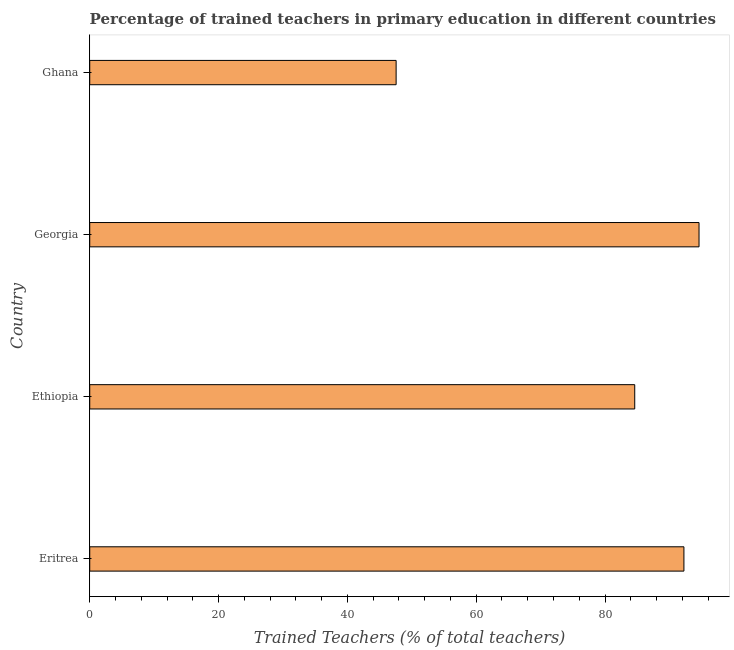Does the graph contain grids?
Give a very brief answer. No. What is the title of the graph?
Your response must be concise. Percentage of trained teachers in primary education in different countries. What is the label or title of the X-axis?
Provide a succinct answer. Trained Teachers (% of total teachers). What is the label or title of the Y-axis?
Provide a short and direct response. Country. What is the percentage of trained teachers in Georgia?
Your answer should be compact. 94.59. Across all countries, what is the maximum percentage of trained teachers?
Offer a very short reply. 94.59. Across all countries, what is the minimum percentage of trained teachers?
Provide a short and direct response. 47.57. In which country was the percentage of trained teachers maximum?
Provide a short and direct response. Georgia. In which country was the percentage of trained teachers minimum?
Make the answer very short. Ghana. What is the sum of the percentage of trained teachers?
Keep it short and to the point. 319.01. What is the difference between the percentage of trained teachers in Eritrea and Ghana?
Ensure brevity in your answer.  44.68. What is the average percentage of trained teachers per country?
Your answer should be compact. 79.75. What is the median percentage of trained teachers?
Your answer should be very brief. 88.43. In how many countries, is the percentage of trained teachers greater than 8 %?
Your answer should be compact. 4. What is the ratio of the percentage of trained teachers in Ethiopia to that in Georgia?
Offer a terse response. 0.89. What is the difference between the highest and the second highest percentage of trained teachers?
Make the answer very short. 2.34. What is the difference between the highest and the lowest percentage of trained teachers?
Make the answer very short. 47.02. How many bars are there?
Your response must be concise. 4. Are all the bars in the graph horizontal?
Give a very brief answer. Yes. How many countries are there in the graph?
Your response must be concise. 4. What is the difference between two consecutive major ticks on the X-axis?
Ensure brevity in your answer.  20. Are the values on the major ticks of X-axis written in scientific E-notation?
Give a very brief answer. No. What is the Trained Teachers (% of total teachers) in Eritrea?
Give a very brief answer. 92.25. What is the Trained Teachers (% of total teachers) in Ethiopia?
Ensure brevity in your answer.  84.61. What is the Trained Teachers (% of total teachers) in Georgia?
Offer a very short reply. 94.59. What is the Trained Teachers (% of total teachers) of Ghana?
Keep it short and to the point. 47.57. What is the difference between the Trained Teachers (% of total teachers) in Eritrea and Ethiopia?
Provide a succinct answer. 7.64. What is the difference between the Trained Teachers (% of total teachers) in Eritrea and Georgia?
Give a very brief answer. -2.34. What is the difference between the Trained Teachers (% of total teachers) in Eritrea and Ghana?
Offer a terse response. 44.68. What is the difference between the Trained Teachers (% of total teachers) in Ethiopia and Georgia?
Offer a terse response. -9.98. What is the difference between the Trained Teachers (% of total teachers) in Ethiopia and Ghana?
Make the answer very short. 37.04. What is the difference between the Trained Teachers (% of total teachers) in Georgia and Ghana?
Ensure brevity in your answer.  47.02. What is the ratio of the Trained Teachers (% of total teachers) in Eritrea to that in Ethiopia?
Offer a terse response. 1.09. What is the ratio of the Trained Teachers (% of total teachers) in Eritrea to that in Georgia?
Your answer should be compact. 0.97. What is the ratio of the Trained Teachers (% of total teachers) in Eritrea to that in Ghana?
Keep it short and to the point. 1.94. What is the ratio of the Trained Teachers (% of total teachers) in Ethiopia to that in Georgia?
Provide a succinct answer. 0.89. What is the ratio of the Trained Teachers (% of total teachers) in Ethiopia to that in Ghana?
Your response must be concise. 1.78. What is the ratio of the Trained Teachers (% of total teachers) in Georgia to that in Ghana?
Offer a terse response. 1.99. 